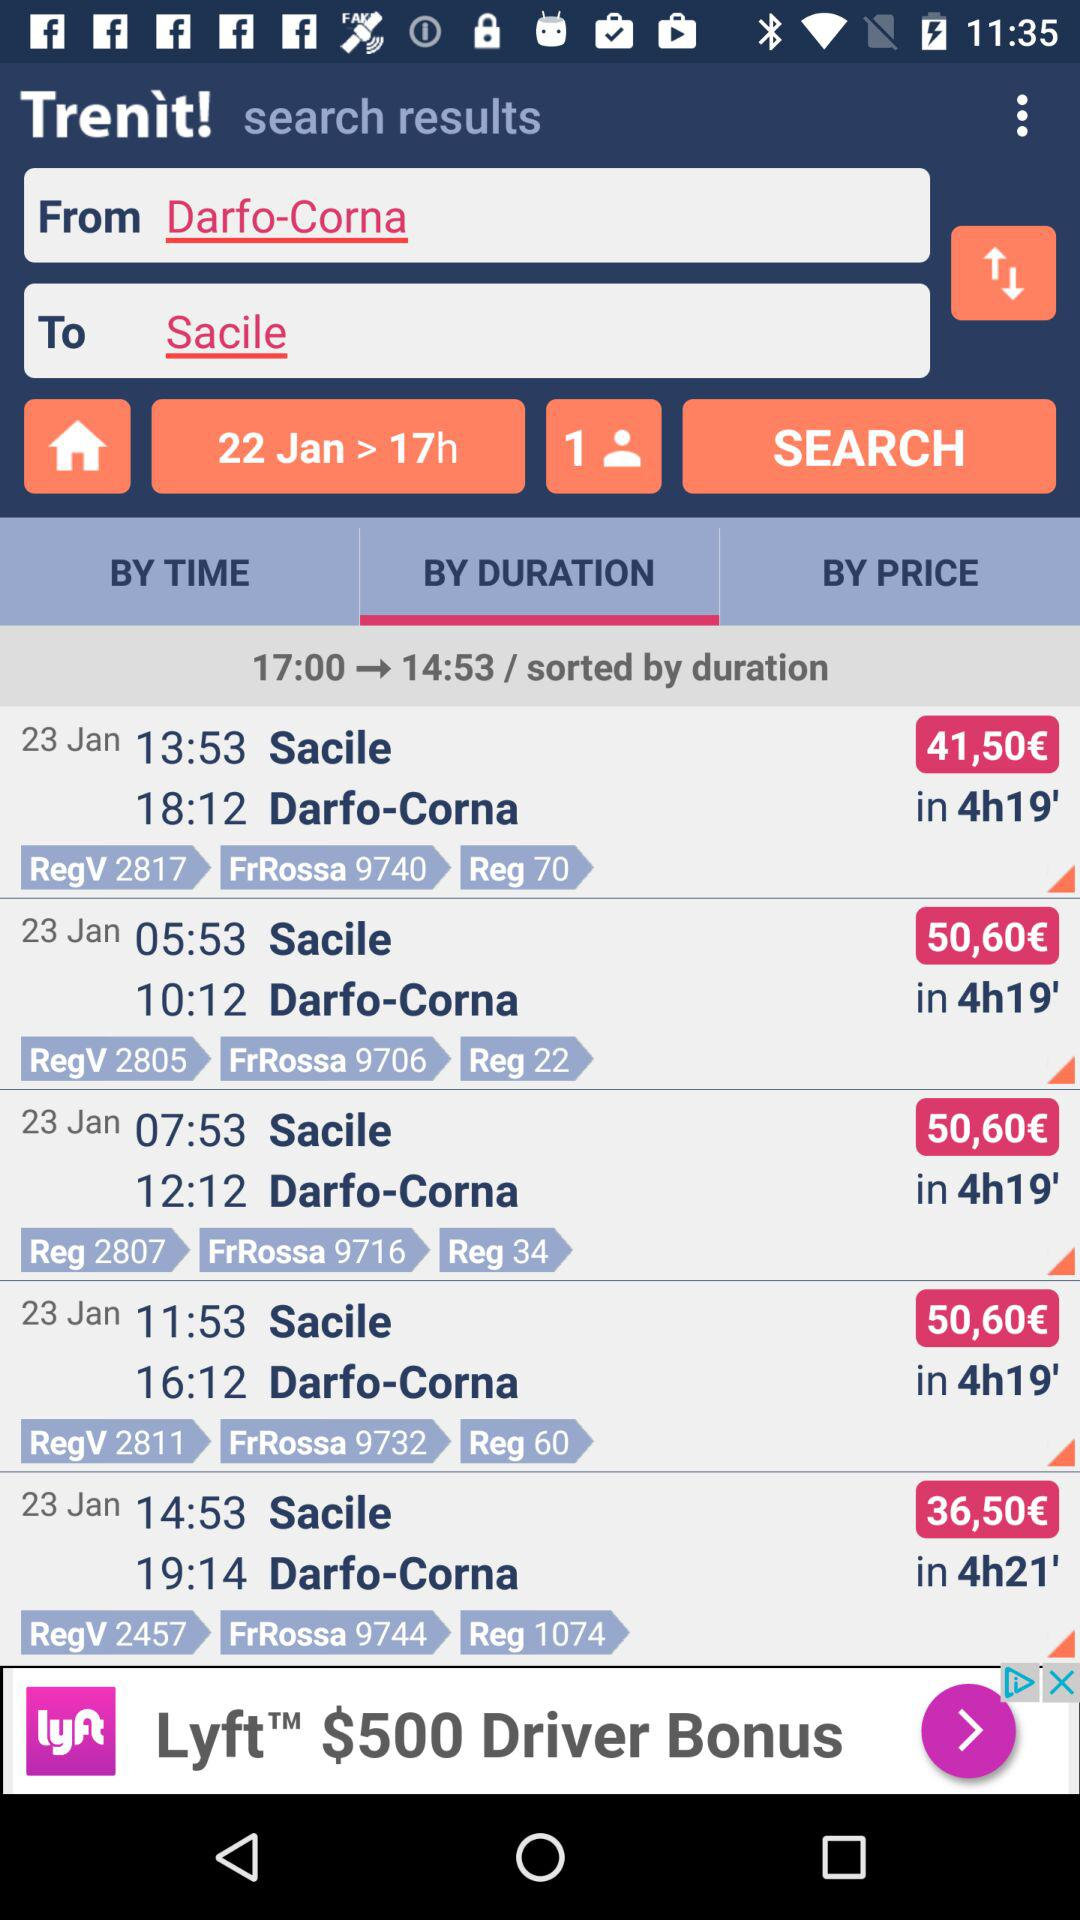For how many people is the flight booking process in progress? The flight booking process in progress is for 1 person. 